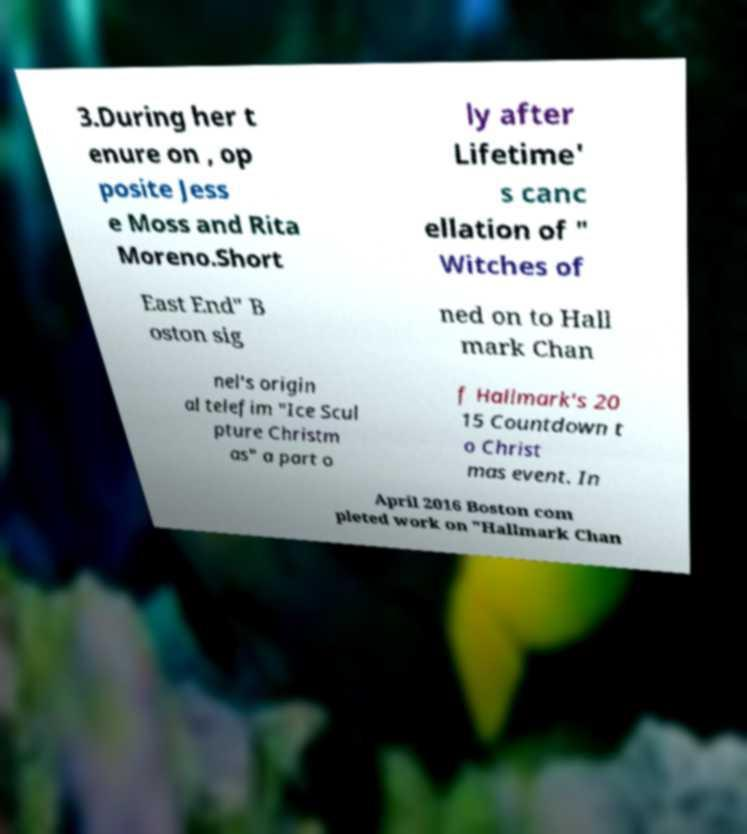Could you extract and type out the text from this image? 3.During her t enure on , op posite Jess e Moss and Rita Moreno.Short ly after Lifetime' s canc ellation of " Witches of East End" B oston sig ned on to Hall mark Chan nel's origin al telefim "Ice Scul pture Christm as" a part o f Hallmark's 20 15 Countdown t o Christ mas event. In April 2016 Boston com pleted work on "Hallmark Chan 